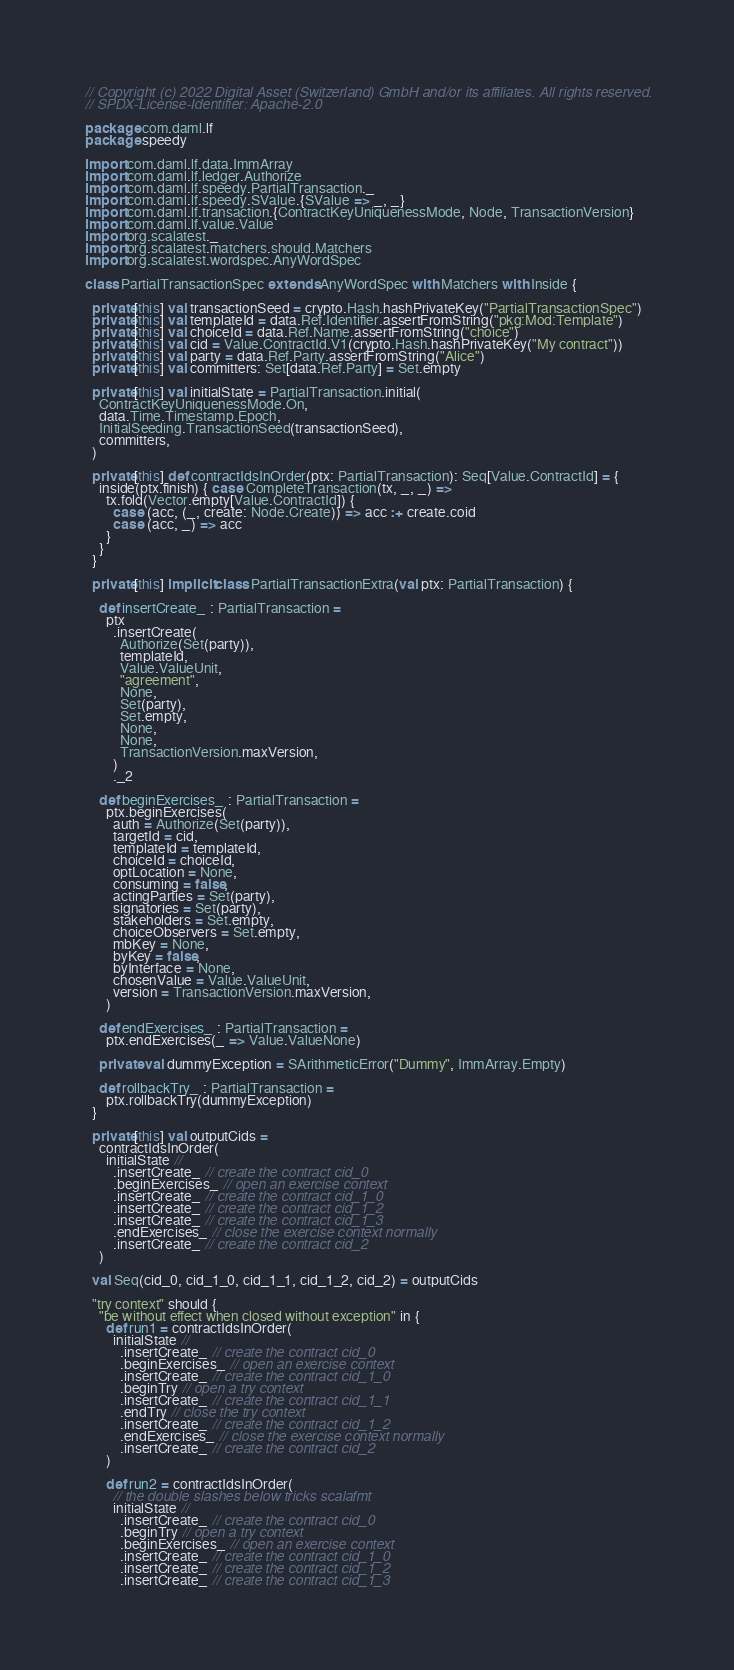<code> <loc_0><loc_0><loc_500><loc_500><_Scala_>// Copyright (c) 2022 Digital Asset (Switzerland) GmbH and/or its affiliates. All rights reserved.
// SPDX-License-Identifier: Apache-2.0

package com.daml.lf
package speedy

import com.daml.lf.data.ImmArray
import com.daml.lf.ledger.Authorize
import com.daml.lf.speedy.PartialTransaction._
import com.daml.lf.speedy.SValue.{SValue => _, _}
import com.daml.lf.transaction.{ContractKeyUniquenessMode, Node, TransactionVersion}
import com.daml.lf.value.Value
import org.scalatest._
import org.scalatest.matchers.should.Matchers
import org.scalatest.wordspec.AnyWordSpec

class PartialTransactionSpec extends AnyWordSpec with Matchers with Inside {

  private[this] val transactionSeed = crypto.Hash.hashPrivateKey("PartialTransactionSpec")
  private[this] val templateId = data.Ref.Identifier.assertFromString("pkg:Mod:Template")
  private[this] val choiceId = data.Ref.Name.assertFromString("choice")
  private[this] val cid = Value.ContractId.V1(crypto.Hash.hashPrivateKey("My contract"))
  private[this] val party = data.Ref.Party.assertFromString("Alice")
  private[this] val committers: Set[data.Ref.Party] = Set.empty

  private[this] val initialState = PartialTransaction.initial(
    ContractKeyUniquenessMode.On,
    data.Time.Timestamp.Epoch,
    InitialSeeding.TransactionSeed(transactionSeed),
    committers,
  )

  private[this] def contractIdsInOrder(ptx: PartialTransaction): Seq[Value.ContractId] = {
    inside(ptx.finish) { case CompleteTransaction(tx, _, _) =>
      tx.fold(Vector.empty[Value.ContractId]) {
        case (acc, (_, create: Node.Create)) => acc :+ create.coid
        case (acc, _) => acc
      }
    }
  }

  private[this] implicit class PartialTransactionExtra(val ptx: PartialTransaction) {

    def insertCreate_ : PartialTransaction =
      ptx
        .insertCreate(
          Authorize(Set(party)),
          templateId,
          Value.ValueUnit,
          "agreement",
          None,
          Set(party),
          Set.empty,
          None,
          None,
          TransactionVersion.maxVersion,
        )
        ._2

    def beginExercises_ : PartialTransaction =
      ptx.beginExercises(
        auth = Authorize(Set(party)),
        targetId = cid,
        templateId = templateId,
        choiceId = choiceId,
        optLocation = None,
        consuming = false,
        actingParties = Set(party),
        signatories = Set(party),
        stakeholders = Set.empty,
        choiceObservers = Set.empty,
        mbKey = None,
        byKey = false,
        byInterface = None,
        chosenValue = Value.ValueUnit,
        version = TransactionVersion.maxVersion,
      )

    def endExercises_ : PartialTransaction =
      ptx.endExercises(_ => Value.ValueNone)

    private val dummyException = SArithmeticError("Dummy", ImmArray.Empty)

    def rollbackTry_ : PartialTransaction =
      ptx.rollbackTry(dummyException)
  }

  private[this] val outputCids =
    contractIdsInOrder(
      initialState //
        .insertCreate_ // create the contract cid_0
        .beginExercises_ // open an exercise context
        .insertCreate_ // create the contract cid_1_0
        .insertCreate_ // create the contract cid_1_2
        .insertCreate_ // create the contract cid_1_3
        .endExercises_ // close the exercise context normally
        .insertCreate_ // create the contract cid_2
    )

  val Seq(cid_0, cid_1_0, cid_1_1, cid_1_2, cid_2) = outputCids

  "try context" should {
    "be without effect when closed without exception" in {
      def run1 = contractIdsInOrder(
        initialState //
          .insertCreate_ // create the contract cid_0
          .beginExercises_ // open an exercise context
          .insertCreate_ // create the contract cid_1_0
          .beginTry // open a try context
          .insertCreate_ // create the contract cid_1_1
          .endTry // close the try context
          .insertCreate_ // create the contract cid_1_2
          .endExercises_ // close the exercise context normally
          .insertCreate_ // create the contract cid_2
      )

      def run2 = contractIdsInOrder(
        // the double slashes below tricks scalafmt
        initialState //
          .insertCreate_ // create the contract cid_0
          .beginTry // open a try context
          .beginExercises_ // open an exercise context
          .insertCreate_ // create the contract cid_1_0
          .insertCreate_ // create the contract cid_1_2
          .insertCreate_ // create the contract cid_1_3</code> 